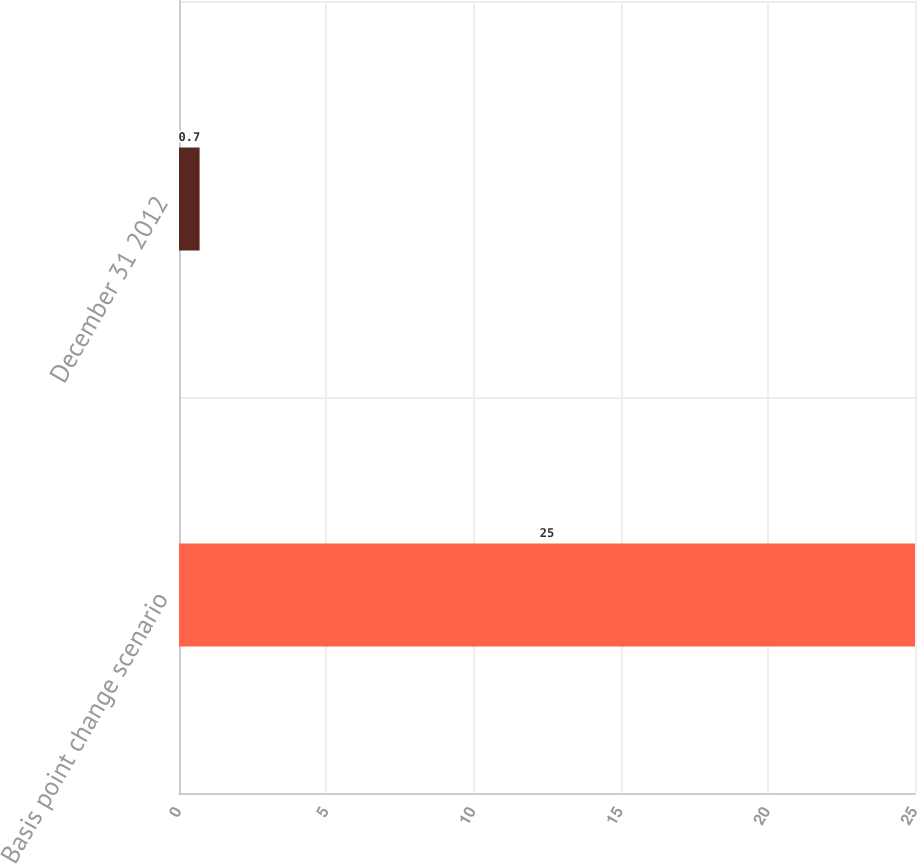Convert chart to OTSL. <chart><loc_0><loc_0><loc_500><loc_500><bar_chart><fcel>Basis point change scenario<fcel>December 31 2012<nl><fcel>25<fcel>0.7<nl></chart> 